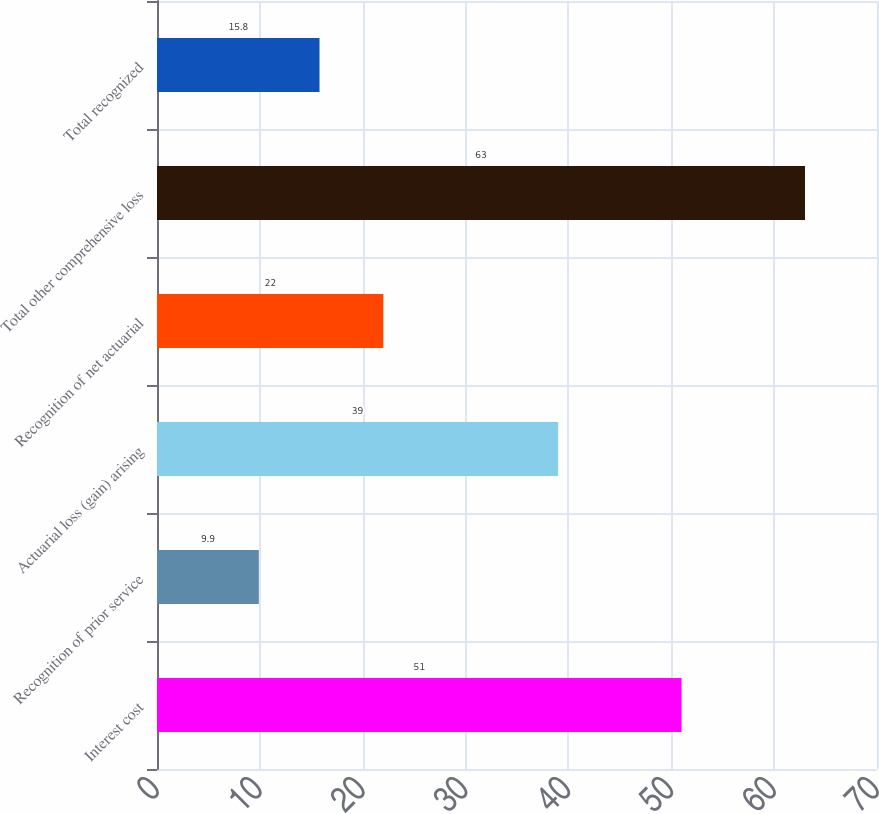Convert chart. <chart><loc_0><loc_0><loc_500><loc_500><bar_chart><fcel>Interest cost<fcel>Recognition of prior service<fcel>Actuarial loss (gain) arising<fcel>Recognition of net actuarial<fcel>Total other comprehensive loss<fcel>Total recognized<nl><fcel>51<fcel>9.9<fcel>39<fcel>22<fcel>63<fcel>15.8<nl></chart> 